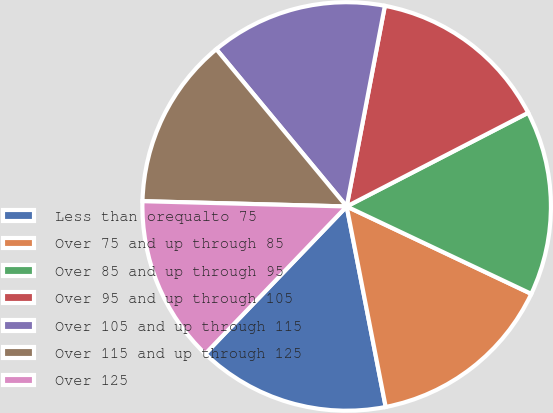<chart> <loc_0><loc_0><loc_500><loc_500><pie_chart><fcel>Less than orequalto 75<fcel>Over 75 and up through 85<fcel>Over 85 and up through 95<fcel>Over 95 and up through 105<fcel>Over 105 and up through 115<fcel>Over 115 and up through 125<fcel>Over 125<nl><fcel>15.23%<fcel>14.9%<fcel>14.62%<fcel>14.42%<fcel>14.01%<fcel>13.57%<fcel>13.24%<nl></chart> 